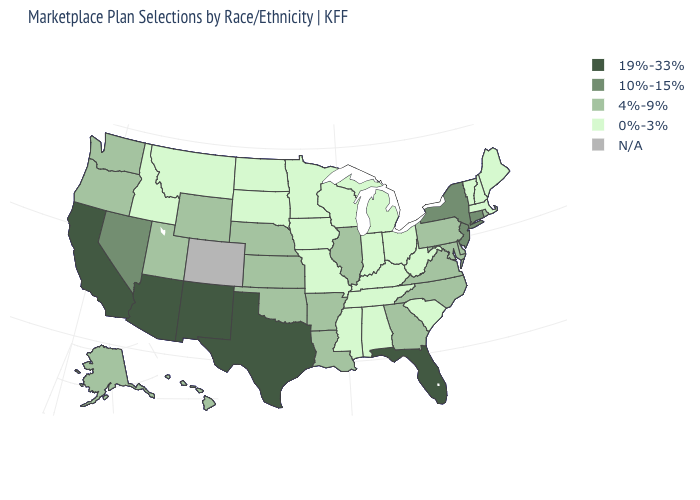What is the value of West Virginia?
Concise answer only. 0%-3%. What is the value of Connecticut?
Give a very brief answer. 10%-15%. Name the states that have a value in the range 4%-9%?
Keep it brief. Alaska, Arkansas, Delaware, Georgia, Hawaii, Illinois, Kansas, Louisiana, Maryland, Nebraska, North Carolina, Oklahoma, Oregon, Pennsylvania, Rhode Island, Utah, Virginia, Washington, Wyoming. What is the value of New Mexico?
Quick response, please. 19%-33%. Name the states that have a value in the range 19%-33%?
Give a very brief answer. Arizona, California, Florida, New Mexico, Texas. What is the lowest value in states that border Nebraska?
Keep it brief. 0%-3%. Does the map have missing data?
Be succinct. Yes. What is the highest value in the MidWest ?
Be succinct. 4%-9%. Does the first symbol in the legend represent the smallest category?
Answer briefly. No. Among the states that border New Mexico , does Utah have the highest value?
Be succinct. No. Which states hav the highest value in the West?
Give a very brief answer. Arizona, California, New Mexico. What is the value of Idaho?
Write a very short answer. 0%-3%. What is the lowest value in the USA?
Write a very short answer. 0%-3%. What is the value of Wisconsin?
Answer briefly. 0%-3%. What is the highest value in states that border Iowa?
Be succinct. 4%-9%. 